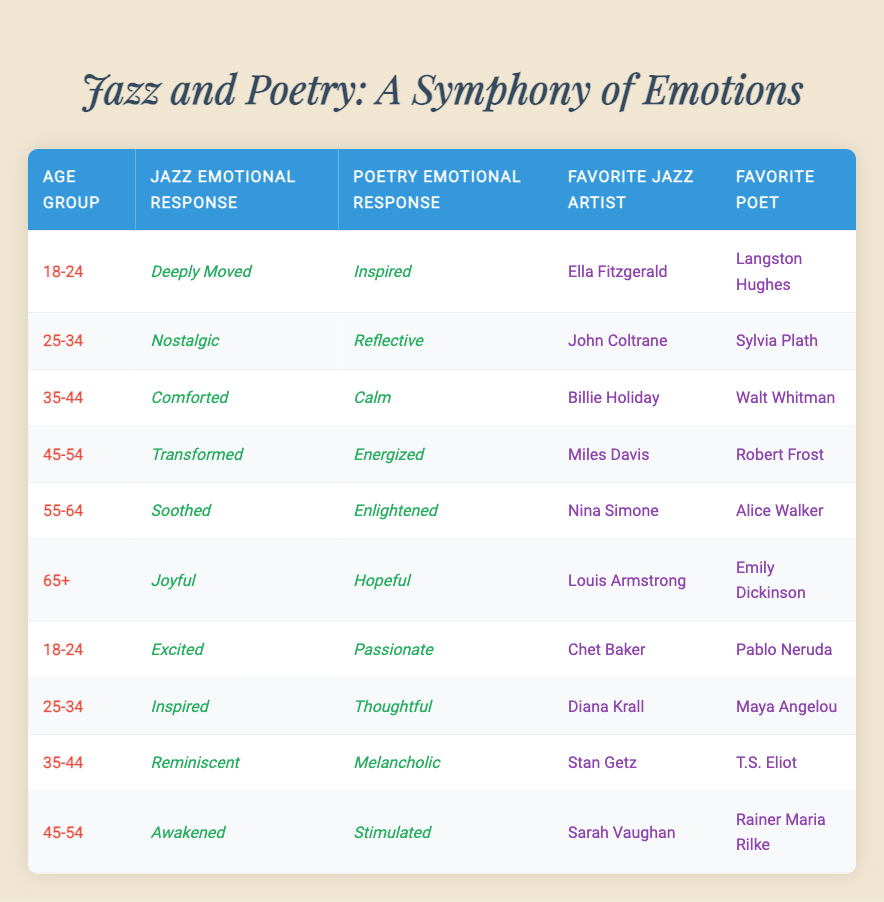What is the jazz emotional response of the 65+ age group? The table lists the emotional responses for each age group. Looking at the row for the 65+ age group, the jazz emotional response is "Joyful."
Answer: Joyful Which age group expressed the emotional response of "Inspired" towards poetry? The table shows each age group's emotional response to poetry. Two age groups have "Inspired": the 18-24 age group (participant 1) and the 25-34 age group (participant 8).
Answer: 18-24 and 25-34 How many participants reported feeling "Transformed" after listening to jazz? From the table, I can see that only one participant (participant 4 in the 45-54 age group) reported feeling "Transformed."
Answer: 1 What are the favorite poets of participants aged 35-44? The table shows the favorite poets of those in the 35-44 age group. According to the table, participant 3 favorites Walt Whitman, and participant 9 favorites T.S. Eliot.
Answer: Walt Whitman and T.S. Eliot Which favorite jazz artist is associated with the emotional response "Energized"? According to the table, the emotional response "Energized" corresponds to participant 4, whose favorite jazz artist is Miles Davis.
Answer: Miles Davis Which age group has the highest emotional response of "Soothed" regarding jazz music? Referring to the table, the 55-64 age group (participant 5) reported being "Soothed." This is the only instance of that response in jazz music.
Answer: 55-64 How many different jazz emotional responses are represented in the survey results? By reviewing the table data, I can see that there are six unique responses for jazz: Deeply Moved, Nostalgic, Comforted, Transformed, Soothed, and Joyful. I can count them all.
Answer: 6 Are there any participants who feel both "Inspired" from jazz and "Excited" from poetry? The table shows the emotional responses. Participant 8 feels "Inspired" from jazz and participant 7 feels "Excited" from poetry, but no one feels both.
Answer: No What is the average age of participants whose favorite jazz artist is Ella Fitzgerald? There is one participant (participant 1 in the 18-24 age group) whose favorite jazz artist is Ella Fitzgerald. Since there's only one, the average is the same as the age group. The age ranges from 18 to 24.
Answer: 21 How many participants in the 45-54 age group reported an emotional response of "Awakened" to jazz music? Analyzing the table, under the 45-54 age group, only one participant (participant 10) reported being "Awakened."
Answer: 1 